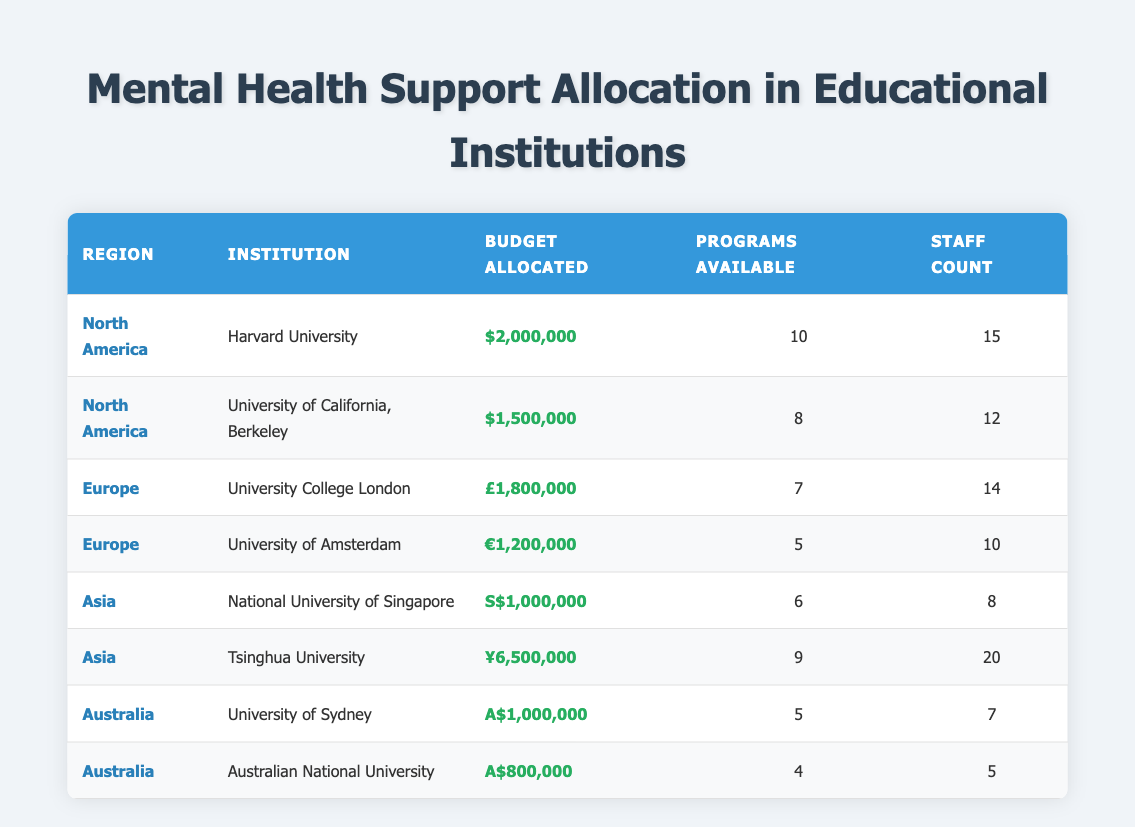What institution has the highest budget allocated for mental health support? The table lists Harvard University with a budget allocated of $2,000,000 in North America, which is the highest among all institutions.
Answer: Harvard University How many programs are available at Tsinghua University? According to the table, Tsinghua University has 9 programs available.
Answer: 9 What is the total budget allocated for mental health support in Asia? The budgets allocated in Asia are S$1,000,000 for the National University of Singapore and ¥6,500,000 for Tsinghua University. To find the total, we add these values directly: S$1,000,000 + ¥6,500,000. Since they are in different currencies, we can't sum them directly without conversion. However, the total is two separate amounts: S$1,000,000 and ¥6,500,000.
Answer: S$1,000,000 and ¥6,500,000 Is it true that all institutions in Europe have more than 5 staff members? Looking at the table, the University College London has 14 staff members and the University of Amsterdam has 10 staff members. Both are greater than 5, so the statement is true.
Answer: Yes Which region has the least average budget allocated per institution? To find the average budget allocated per institution by region, we need to calculate for each region. North America has two institutions with a total of $3,500,000 (average $1,750,000). Europe has two institutions with a total budget of £3,000,000 (average £1,500,000). Asia has two institutions with a total budget of S$1,000,000 and ¥6,500,000, which can’t be averaged directly. Australia has two institutions with a total budget of A$1,800,000 (average A$900,000). The region with the least average budget allocated is Australia, with an average of A$900,000.
Answer: Australia 